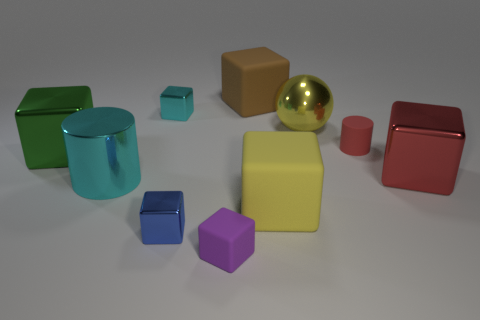Subtract all tiny purple matte blocks. How many blocks are left? 6 Subtract all cylinders. How many objects are left? 8 Subtract 1 red cylinders. How many objects are left? 9 Subtract 1 cylinders. How many cylinders are left? 1 Subtract all purple cubes. Subtract all purple spheres. How many cubes are left? 6 Subtract all purple blocks. How many cyan cylinders are left? 1 Subtract all big green blocks. Subtract all purple matte objects. How many objects are left? 8 Add 6 big rubber blocks. How many big rubber blocks are left? 8 Add 2 large green metal objects. How many large green metal objects exist? 3 Subtract all red cubes. How many cubes are left? 6 